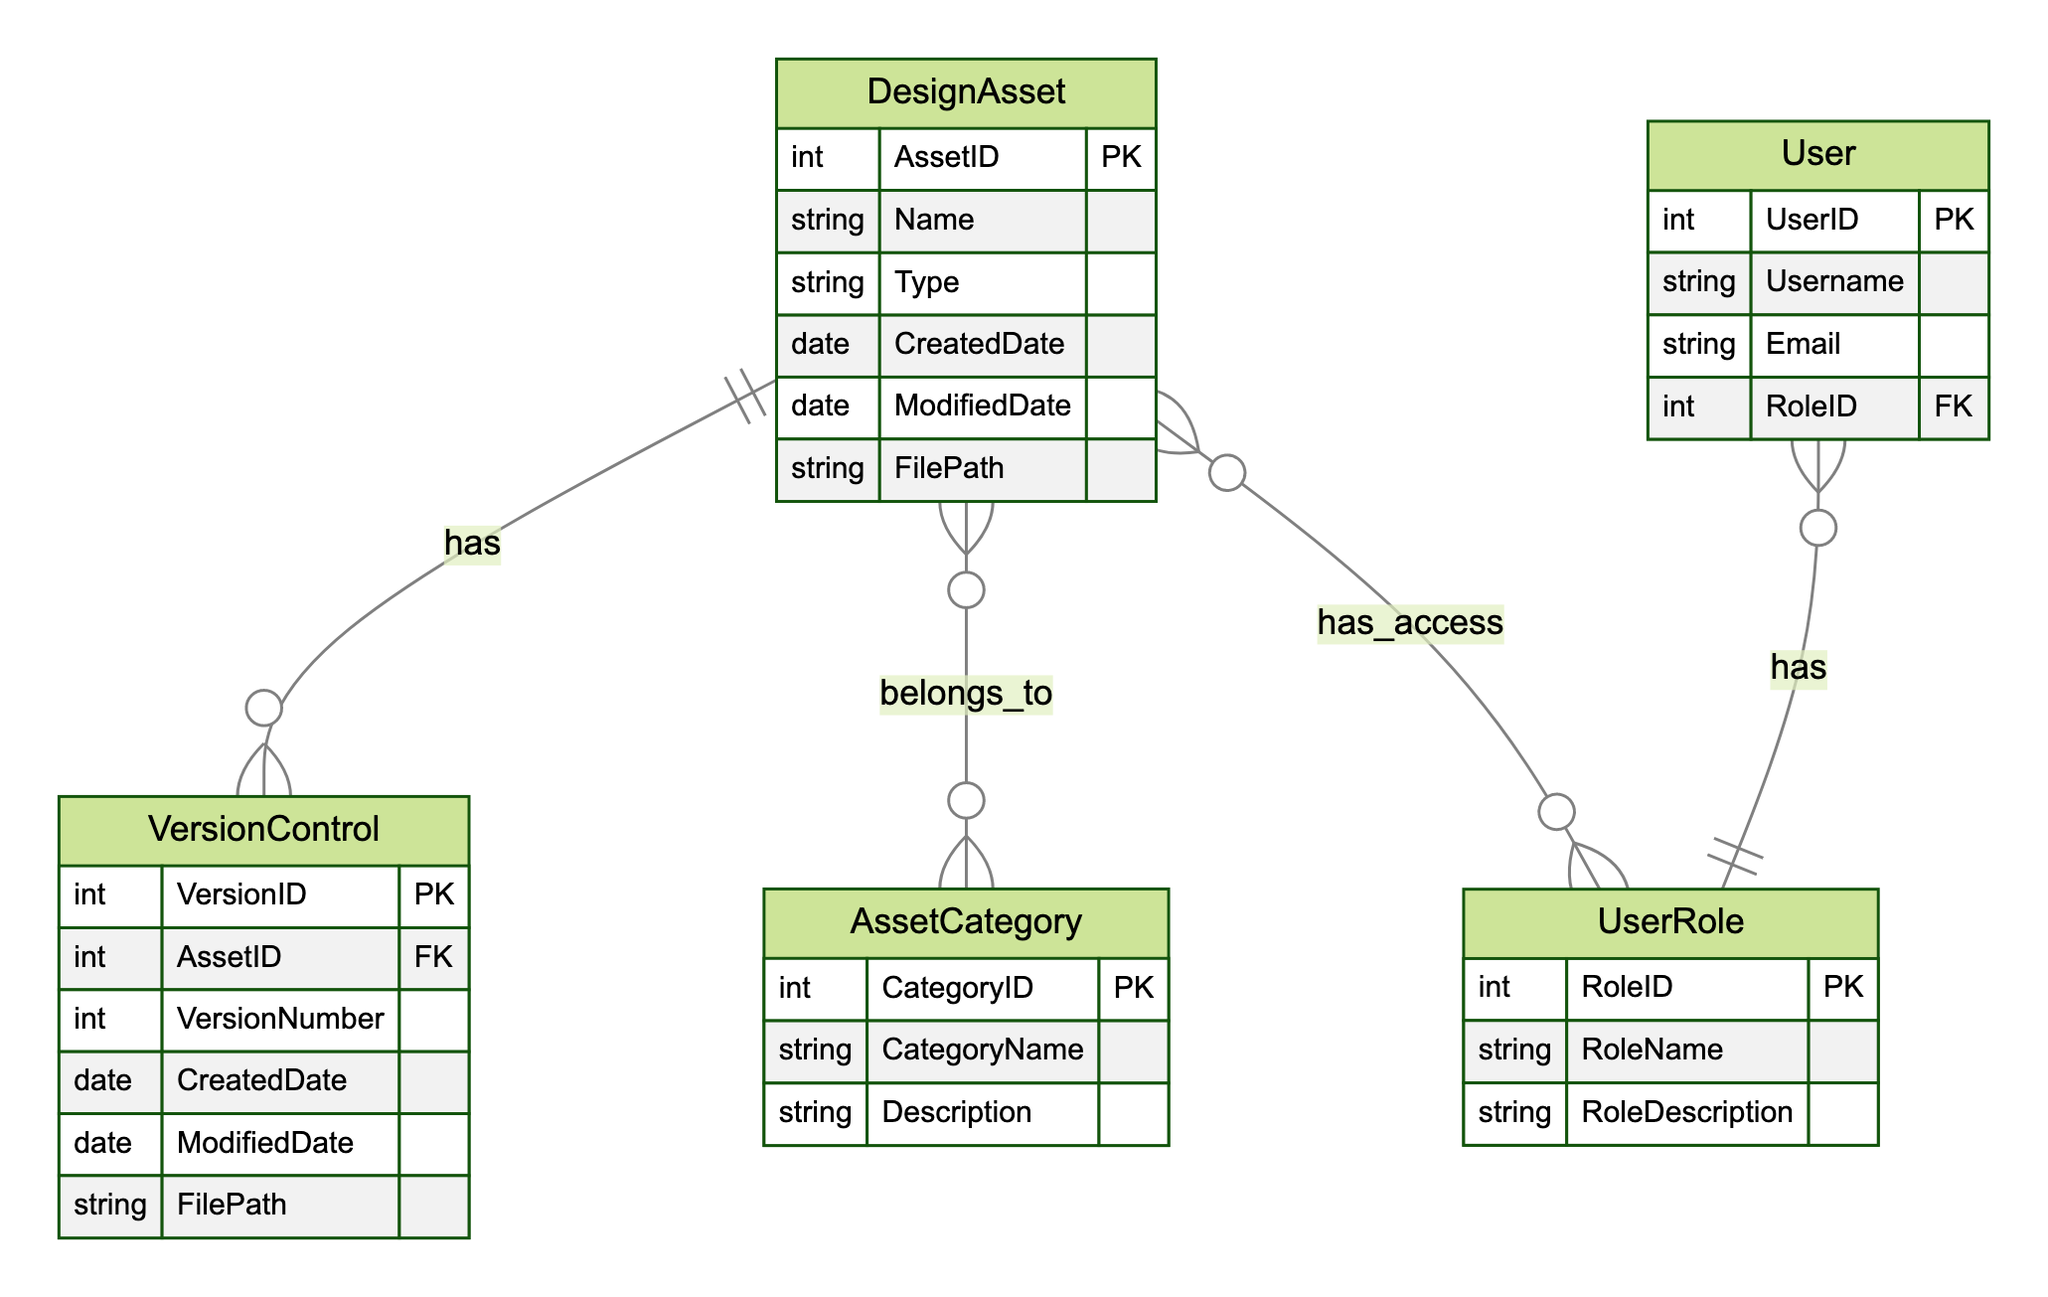What is the primary key of the DesignAsset entity? The primary key of the DesignAsset entity is AssetID, which uniquely identifies each design asset in the library.
Answer: AssetID How many unique entities are present in the diagram? The diagram contains five unique entities: DesignAsset, AssetCategory, UserRole, User, and VersionControl.
Answer: Five What type of relationship exists between DesignAsset and AssetCategory? The relationship between DesignAsset and AssetCategory is many-to-many, indicating that multiple design assets can belong to multiple categories.
Answer: Many-to-many Which entity does UserRole relate to in a many-to-one relationship? The UserRole entity relates to the User entity in a many-to-one relationship, suggesting that multiple users can have the same role.
Answer: User How many attributes does the VersionControl entity have? The VersionControl entity has six attributes: VersionID, AssetID, VersionNumber, CreatedDate, ModifiedDate, and FilePath.
Answer: Six What is the relationship between DesignAsset and VersionControl? The relationship between DesignAsset and VersionControl is one-to-many, meaning that one design asset can have multiple versions tracked in version control.
Answer: One-to-many What does the roleID in User represent? The roleID in User represents a foreign key linking the User entity to the UserRole entity, indicating the role assigned to the user.
Answer: Foreign key What type of data is stored in the ModifiedDate attribute of DesignAsset? The ModifiedDate attribute of DesignAsset stores date data that reflects the last time the asset was modified.
Answer: Date How many relationships are depicted in the diagram? The diagram depicts four relationships: between DesignAsset and AssetCategory, DesignAsset and UserRole, User and UserRole, and VersionControl and DesignAsset.
Answer: Four 